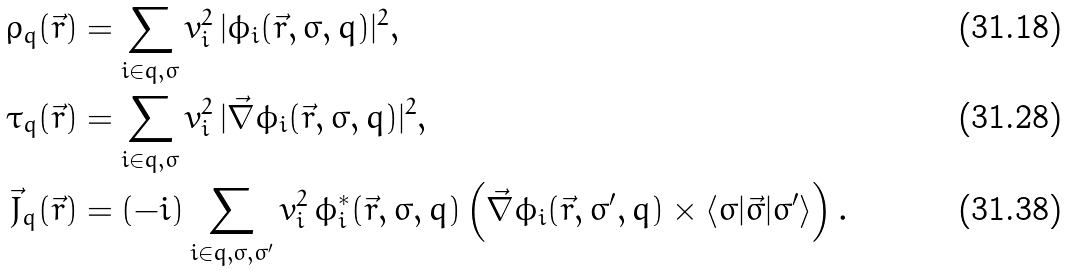<formula> <loc_0><loc_0><loc_500><loc_500>\rho _ { q } ( \vec { r } ) & = \sum _ { i \in q , \sigma } v _ { i } ^ { 2 } \, | \phi _ { i } ( \vec { r } , \sigma , q ) | ^ { 2 } , \\ \tau _ { q } ( \vec { r } ) & = \sum _ { i \in q , \sigma } v _ { i } ^ { 2 } \, | \vec { \nabla } \phi _ { i } ( \vec { r } , \sigma , q ) | ^ { 2 } , \\ \vec { J } _ { q } ( \vec { r } ) & = ( - i ) \sum _ { i \in q , \sigma , \sigma ^ { \prime } } v _ { i } ^ { 2 } \, \phi _ { i } ^ { * } ( \vec { r } , \sigma , q ) \left ( \vec { \nabla } \phi _ { i } ( \vec { r } , \sigma ^ { \prime } , q ) \times \langle \sigma | \vec { \sigma } | \sigma ^ { \prime } \rangle \right ) .</formula> 